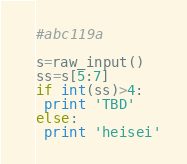Convert code to text. <code><loc_0><loc_0><loc_500><loc_500><_Python_>#abc119a

s=raw_input()
ss=s[5:7]
if int(ss)>4:
 print 'TBD'
else:
 print 'heisei'
</code> 